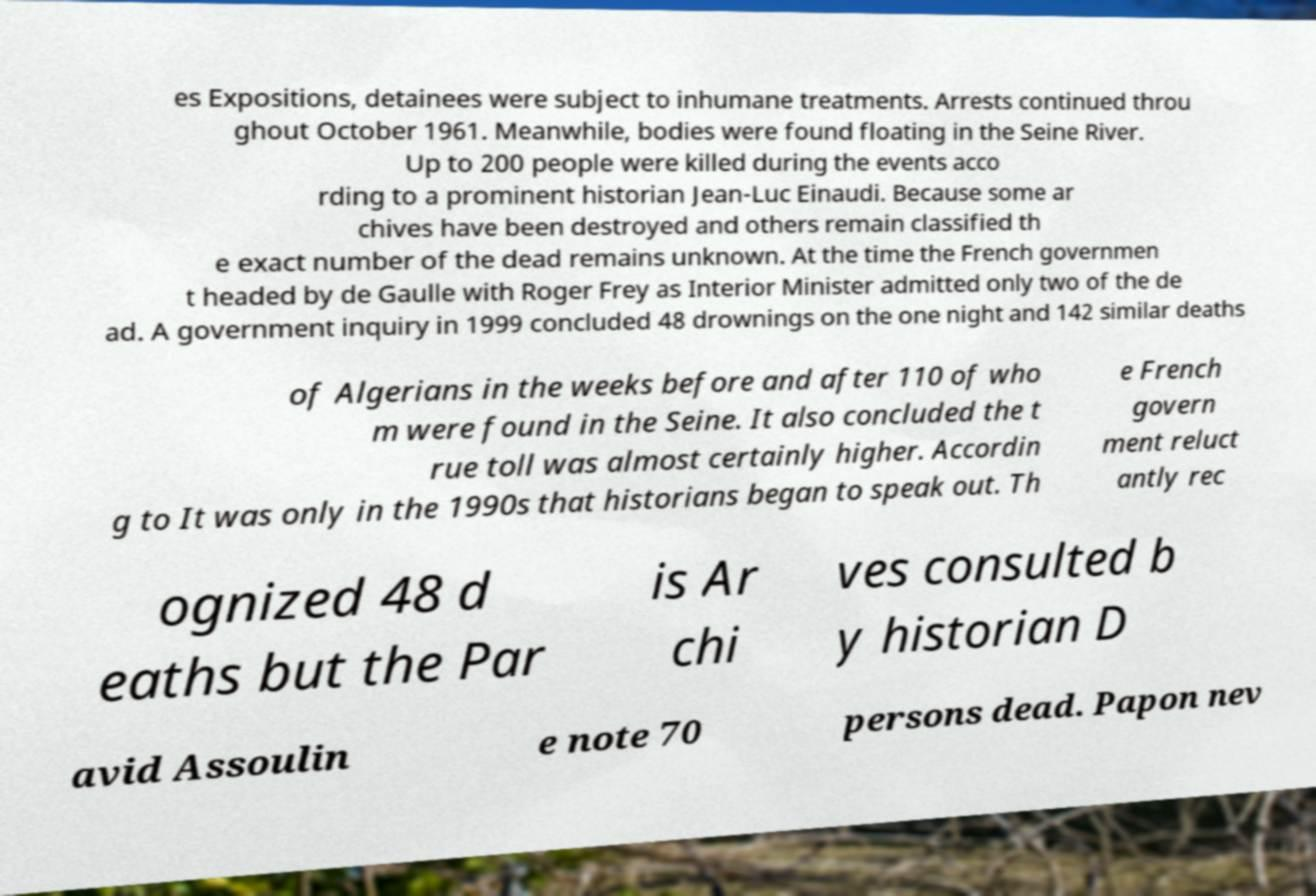For documentation purposes, I need the text within this image transcribed. Could you provide that? es Expositions, detainees were subject to inhumane treatments. Arrests continued throu ghout October 1961. Meanwhile, bodies were found floating in the Seine River. Up to 200 people were killed during the events acco rding to a prominent historian Jean-Luc Einaudi. Because some ar chives have been destroyed and others remain classified th e exact number of the dead remains unknown. At the time the French governmen t headed by de Gaulle with Roger Frey as Interior Minister admitted only two of the de ad. A government inquiry in 1999 concluded 48 drownings on the one night and 142 similar deaths of Algerians in the weeks before and after 110 of who m were found in the Seine. It also concluded the t rue toll was almost certainly higher. Accordin g to It was only in the 1990s that historians began to speak out. Th e French govern ment reluct antly rec ognized 48 d eaths but the Par is Ar chi ves consulted b y historian D avid Assoulin e note 70 persons dead. Papon nev 